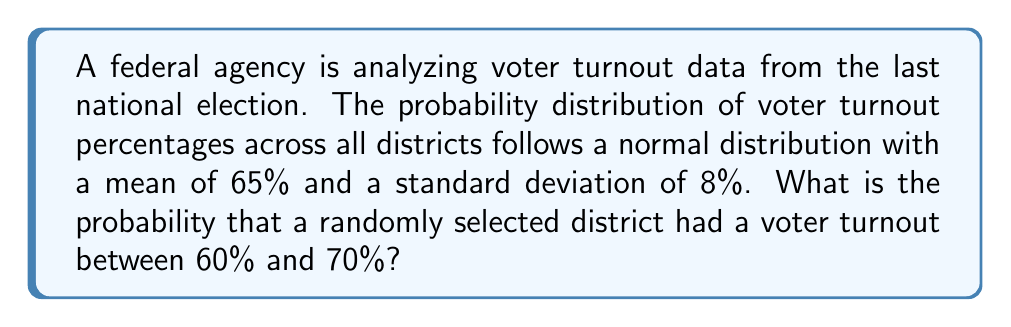What is the answer to this math problem? Let's approach this step-by-step:

1) We are dealing with a normal distribution where:
   $\mu = 65\%$ (mean)
   $\sigma = 8\%$ (standard deviation)

2) We need to find the probability of a district having a turnout between 60% and 70%.

3) To do this, we need to convert these percentages to z-scores:

   For 60%: $z_1 = \frac{60 - 65}{8} = -0.625$
   For 70%: $z_2 = \frac{70 - 65}{8} = 0.625$

4) Now, we need to find the area under the standard normal curve between these z-scores.

5) Using a standard normal table or calculator:
   $P(Z \leq 0.625) = 0.7340$
   $P(Z \leq -0.625) = 0.2660$

6) The probability we're looking for is the difference between these:

   $P(-0.625 \leq Z \leq 0.625) = 0.7340 - 0.2660 = 0.4680$

7) Therefore, the probability that a randomly selected district had a voter turnout between 60% and 70% is 0.4680 or 46.80%.

This analysis allows the federal agency to understand the distribution of voter turnout, which could be used to inform policies aimed at increasing participation in federal elections.
Answer: 0.4680 or 46.80% 